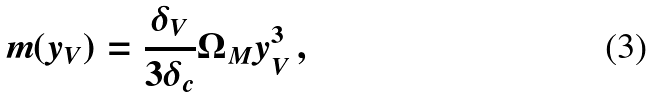Convert formula to latex. <formula><loc_0><loc_0><loc_500><loc_500>m ( y _ { V } ) = \frac { \delta _ { V } } { 3 \delta _ { c } } \Omega _ { M } y _ { V } ^ { 3 } \, ,</formula> 